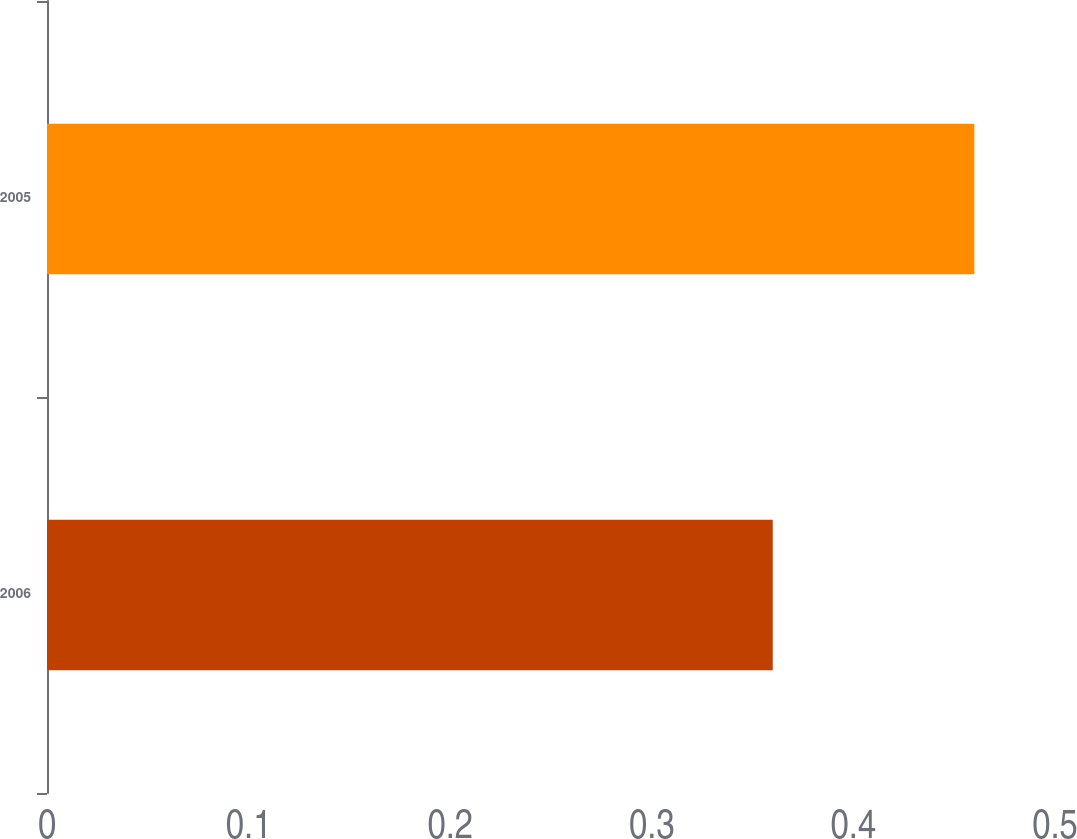Convert chart. <chart><loc_0><loc_0><loc_500><loc_500><bar_chart><fcel>2006<fcel>2005<nl><fcel>0.36<fcel>0.46<nl></chart> 